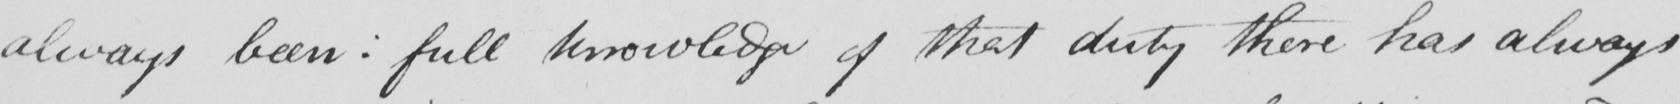What does this handwritten line say? always been :  full knowledge of that duty there has always 